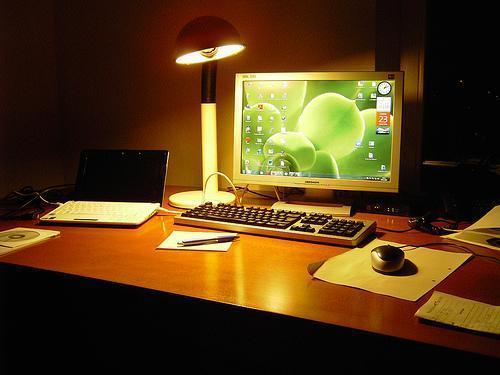How many lamps are pictured?
Give a very brief answer. 1. 